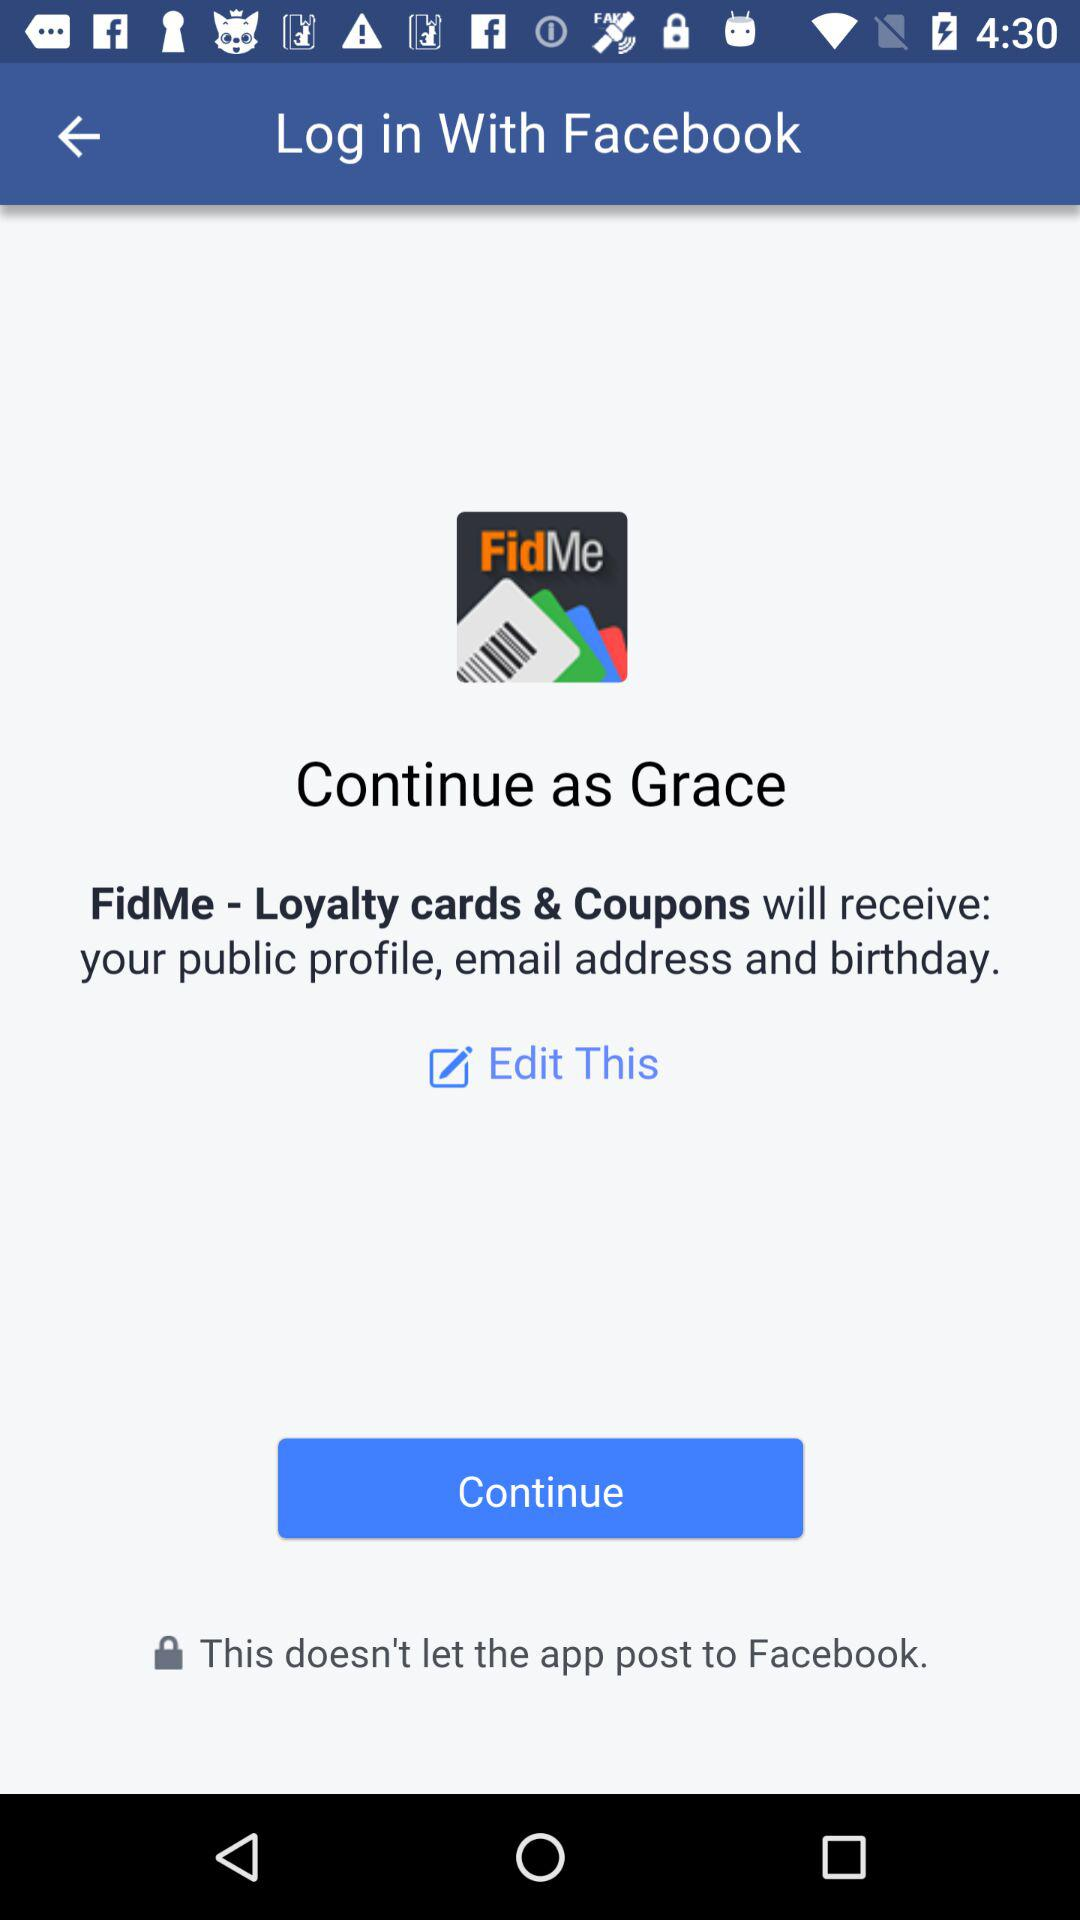What is the userid?
When the provided information is insufficient, respond with <no answer>. <no answer> 